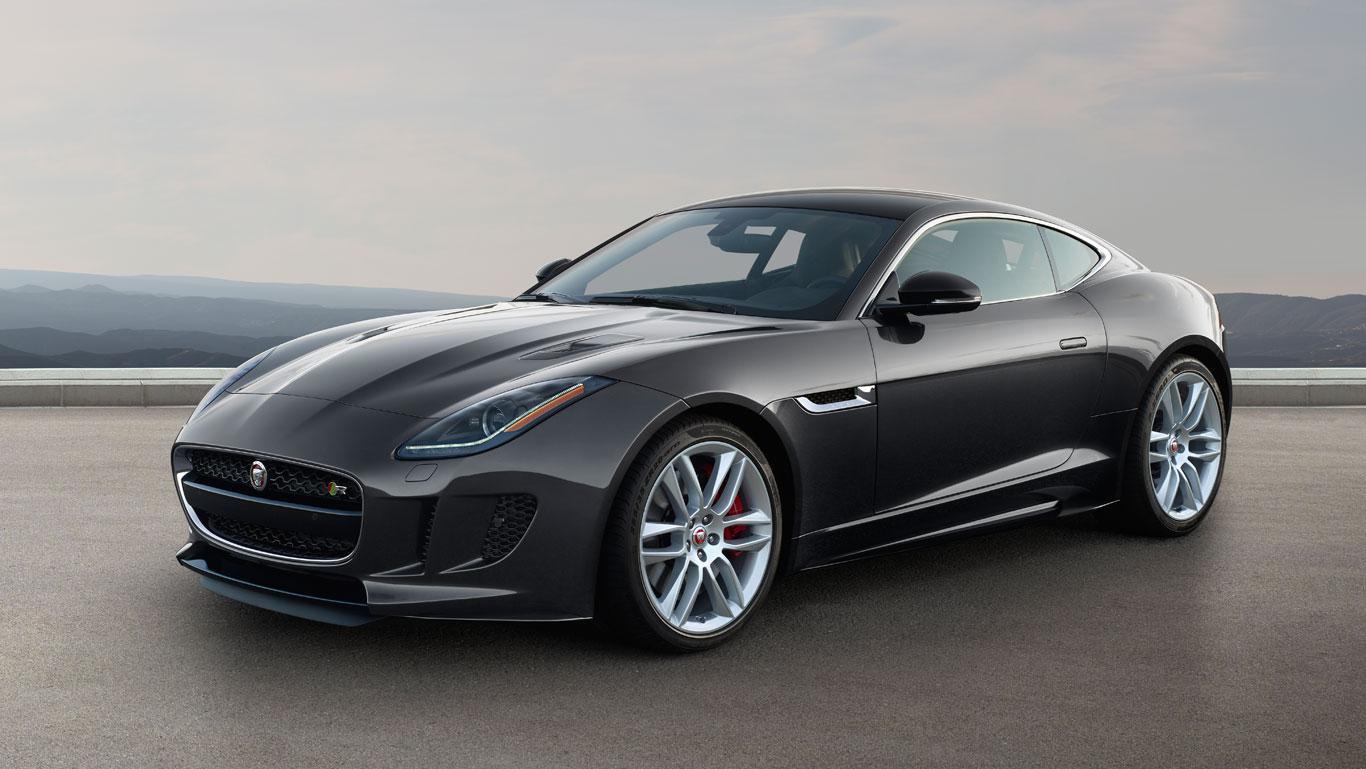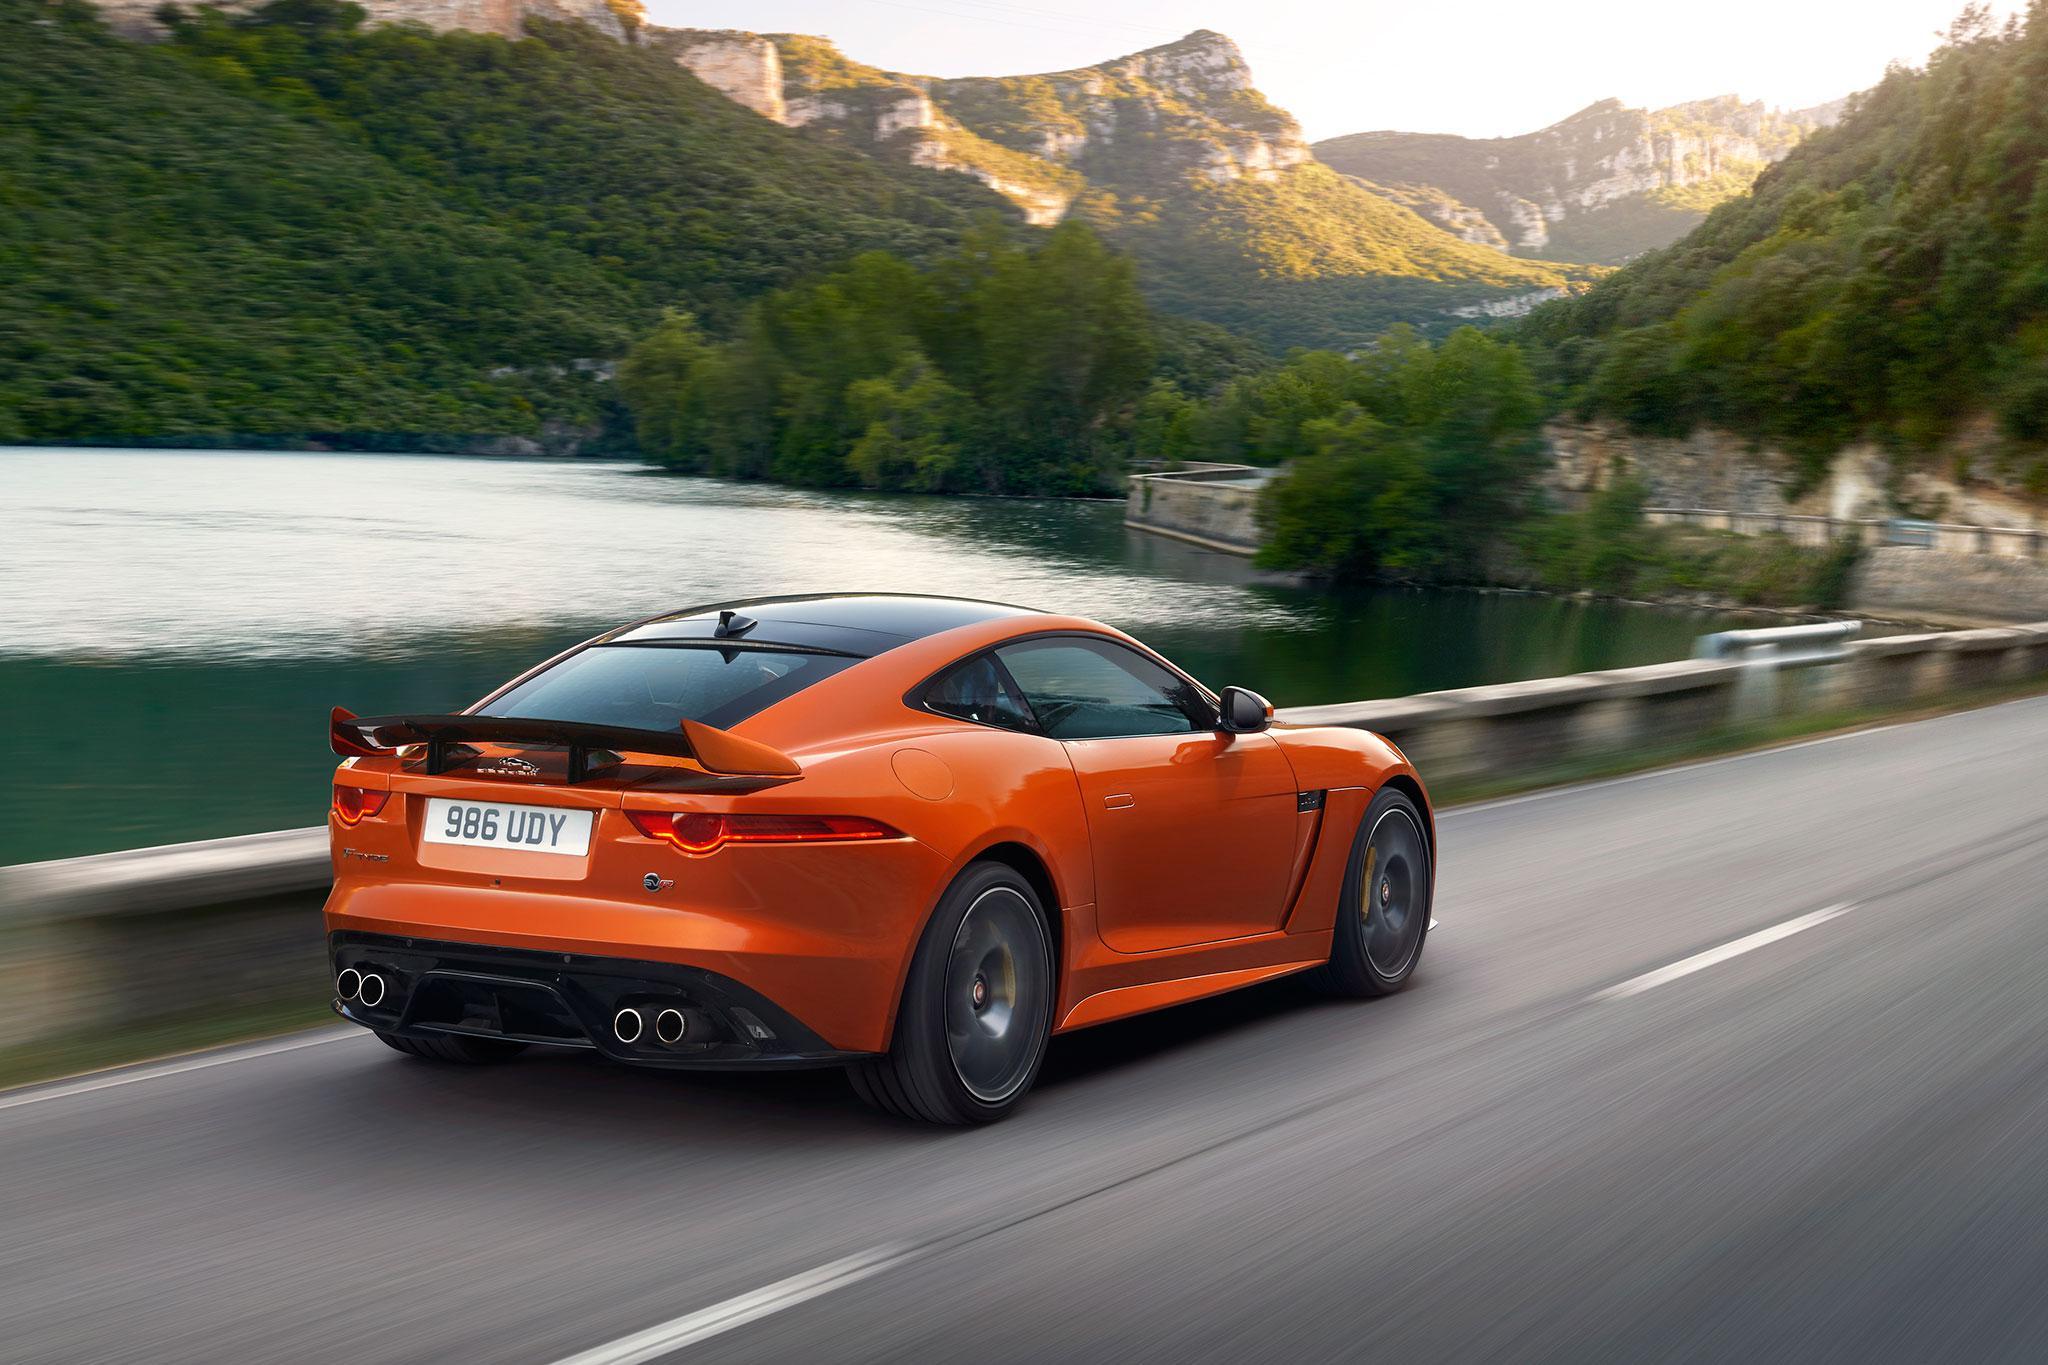The first image is the image on the left, the second image is the image on the right. Given the left and right images, does the statement "There is one car with its top down and one car with the top up" hold true? Answer yes or no. No. The first image is the image on the left, the second image is the image on the right. Given the left and right images, does the statement "The cars in the left and right images face the same direction, but one has its top up and one has its top down." hold true? Answer yes or no. No. 